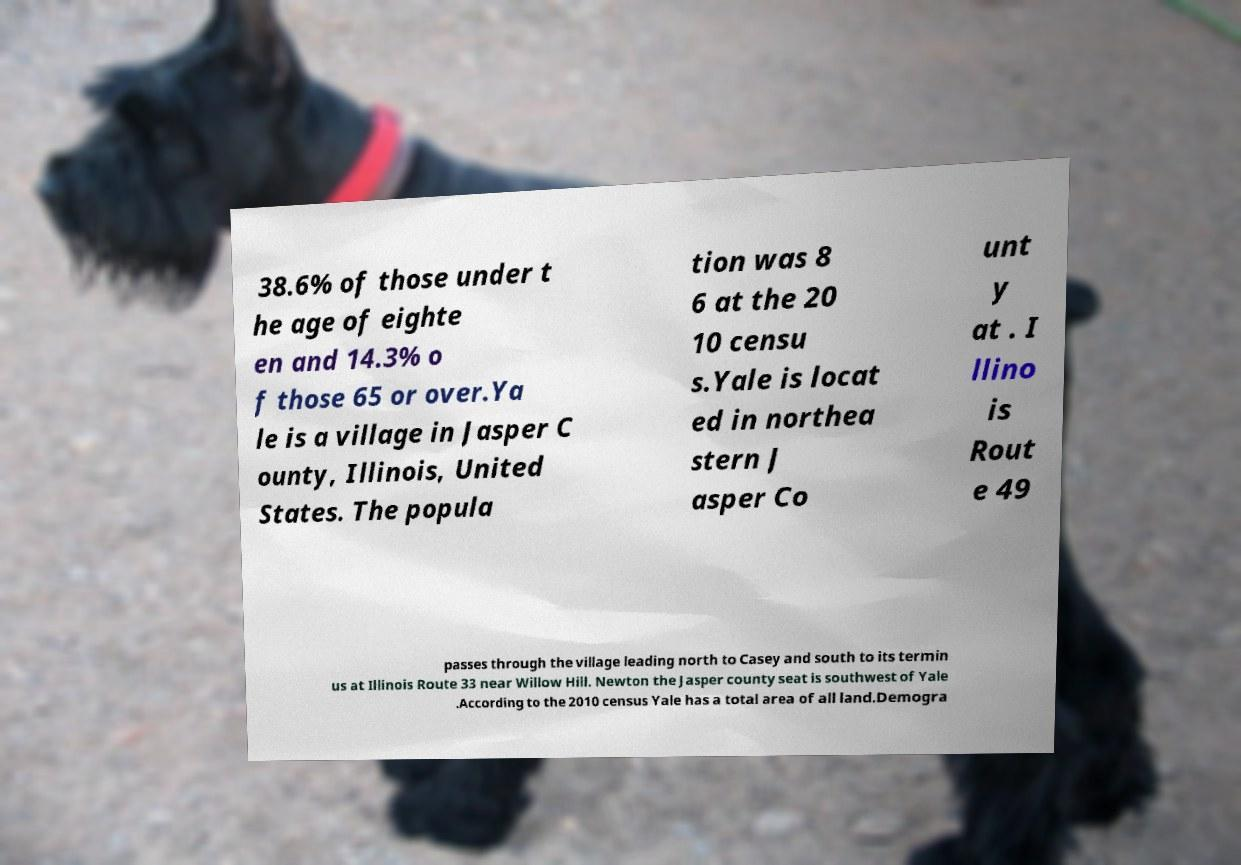For documentation purposes, I need the text within this image transcribed. Could you provide that? 38.6% of those under t he age of eighte en and 14.3% o f those 65 or over.Ya le is a village in Jasper C ounty, Illinois, United States. The popula tion was 8 6 at the 20 10 censu s.Yale is locat ed in northea stern J asper Co unt y at . I llino is Rout e 49 passes through the village leading north to Casey and south to its termin us at Illinois Route 33 near Willow Hill. Newton the Jasper county seat is southwest of Yale .According to the 2010 census Yale has a total area of all land.Demogra 